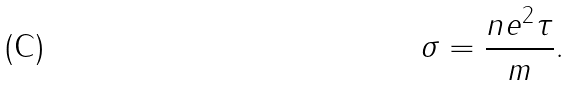Convert formula to latex. <formula><loc_0><loc_0><loc_500><loc_500>\sigma = \frac { n e ^ { 2 } \tau } { m } .</formula> 